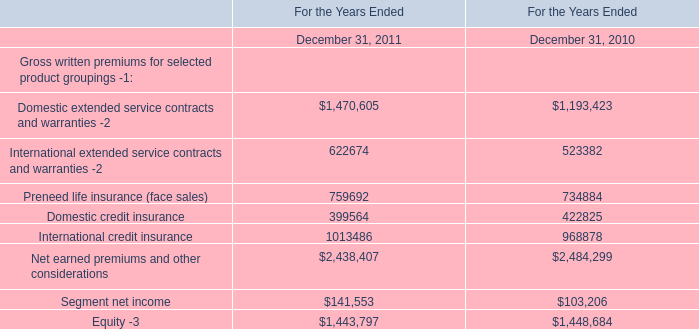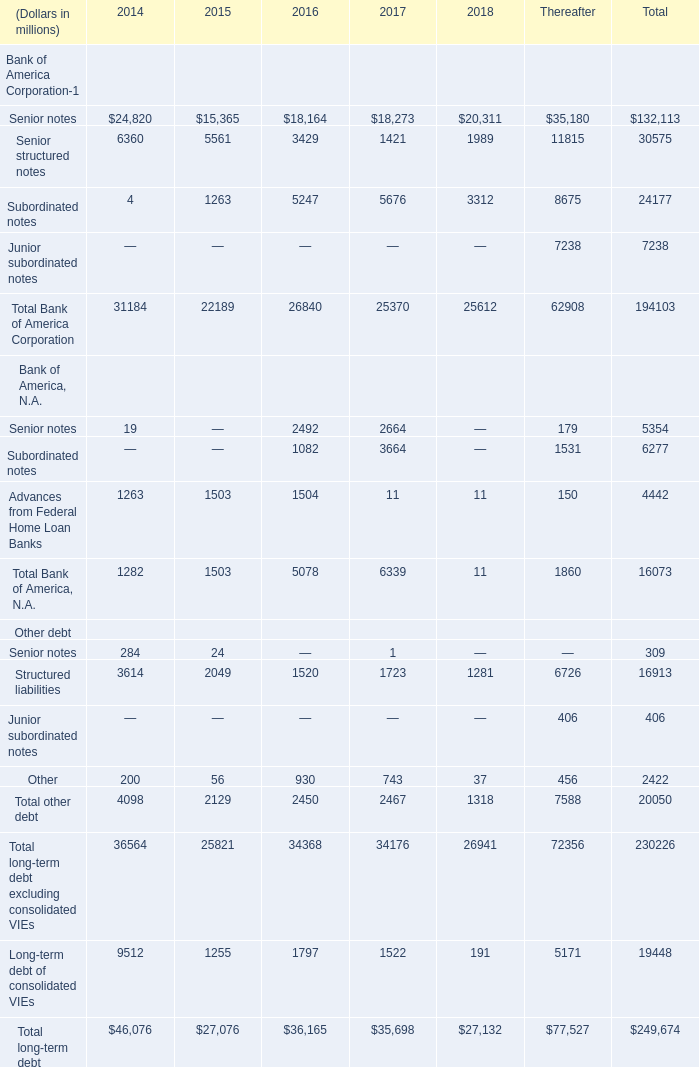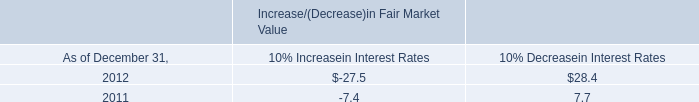What's the average of Bank of America Corporation in 2016? (in million) 
Computations: (26840 / 4)
Answer: 6710.0. 